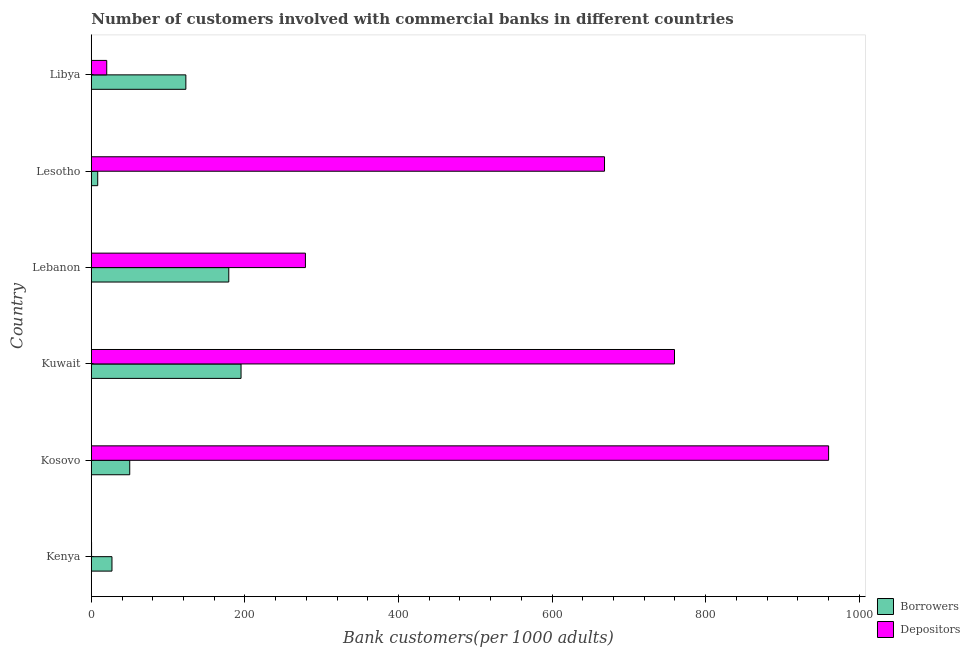How many groups of bars are there?
Your response must be concise. 6. Are the number of bars per tick equal to the number of legend labels?
Offer a terse response. Yes. How many bars are there on the 4th tick from the top?
Make the answer very short. 2. What is the label of the 2nd group of bars from the top?
Provide a short and direct response. Lesotho. What is the number of depositors in Kosovo?
Your answer should be compact. 960.24. Across all countries, what is the maximum number of depositors?
Ensure brevity in your answer.  960.24. Across all countries, what is the minimum number of borrowers?
Your answer should be compact. 8.36. In which country was the number of borrowers maximum?
Keep it short and to the point. Kuwait. In which country was the number of borrowers minimum?
Make the answer very short. Lesotho. What is the total number of depositors in the graph?
Offer a very short reply. 2687.5. What is the difference between the number of depositors in Kenya and that in Libya?
Keep it short and to the point. -19.77. What is the difference between the number of borrowers in Kuwait and the number of depositors in Lebanon?
Make the answer very short. -83.83. What is the average number of depositors per country?
Offer a terse response. 447.92. What is the difference between the number of borrowers and number of depositors in Kenya?
Make the answer very short. 26.58. What is the ratio of the number of depositors in Kenya to that in Kosovo?
Make the answer very short. 0. Is the number of depositors in Kenya less than that in Lesotho?
Make the answer very short. Yes. Is the difference between the number of borrowers in Kuwait and Lebanon greater than the difference between the number of depositors in Kuwait and Lebanon?
Your answer should be compact. No. What is the difference between the highest and the second highest number of depositors?
Your response must be concise. 200.7. What is the difference between the highest and the lowest number of depositors?
Your answer should be very brief. 959.89. In how many countries, is the number of borrowers greater than the average number of borrowers taken over all countries?
Your response must be concise. 3. Is the sum of the number of depositors in Lebanon and Lesotho greater than the maximum number of borrowers across all countries?
Keep it short and to the point. Yes. What does the 2nd bar from the top in Kosovo represents?
Provide a short and direct response. Borrowers. What does the 1st bar from the bottom in Kuwait represents?
Make the answer very short. Borrowers. Are all the bars in the graph horizontal?
Your answer should be very brief. Yes. How many countries are there in the graph?
Your answer should be compact. 6. Does the graph contain any zero values?
Your answer should be very brief. No. Does the graph contain grids?
Ensure brevity in your answer.  No. Where does the legend appear in the graph?
Your answer should be compact. Bottom right. How many legend labels are there?
Offer a terse response. 2. How are the legend labels stacked?
Offer a very short reply. Vertical. What is the title of the graph?
Your response must be concise. Number of customers involved with commercial banks in different countries. What is the label or title of the X-axis?
Provide a short and direct response. Bank customers(per 1000 adults). What is the Bank customers(per 1000 adults) of Borrowers in Kenya?
Your answer should be compact. 26.93. What is the Bank customers(per 1000 adults) of Depositors in Kenya?
Your answer should be compact. 0.35. What is the Bank customers(per 1000 adults) of Borrowers in Kosovo?
Your response must be concise. 50.07. What is the Bank customers(per 1000 adults) of Depositors in Kosovo?
Ensure brevity in your answer.  960.24. What is the Bank customers(per 1000 adults) of Borrowers in Kuwait?
Your answer should be very brief. 195.03. What is the Bank customers(per 1000 adults) of Depositors in Kuwait?
Ensure brevity in your answer.  759.54. What is the Bank customers(per 1000 adults) in Borrowers in Lebanon?
Offer a terse response. 179.06. What is the Bank customers(per 1000 adults) in Depositors in Lebanon?
Keep it short and to the point. 278.86. What is the Bank customers(per 1000 adults) of Borrowers in Lesotho?
Your response must be concise. 8.36. What is the Bank customers(per 1000 adults) of Depositors in Lesotho?
Your answer should be very brief. 668.4. What is the Bank customers(per 1000 adults) in Borrowers in Libya?
Offer a very short reply. 123.15. What is the Bank customers(per 1000 adults) of Depositors in Libya?
Offer a terse response. 20.11. Across all countries, what is the maximum Bank customers(per 1000 adults) in Borrowers?
Provide a short and direct response. 195.03. Across all countries, what is the maximum Bank customers(per 1000 adults) of Depositors?
Give a very brief answer. 960.24. Across all countries, what is the minimum Bank customers(per 1000 adults) in Borrowers?
Give a very brief answer. 8.36. Across all countries, what is the minimum Bank customers(per 1000 adults) of Depositors?
Provide a short and direct response. 0.35. What is the total Bank customers(per 1000 adults) in Borrowers in the graph?
Offer a very short reply. 582.61. What is the total Bank customers(per 1000 adults) of Depositors in the graph?
Your answer should be compact. 2687.5. What is the difference between the Bank customers(per 1000 adults) of Borrowers in Kenya and that in Kosovo?
Make the answer very short. -23.14. What is the difference between the Bank customers(per 1000 adults) of Depositors in Kenya and that in Kosovo?
Offer a terse response. -959.89. What is the difference between the Bank customers(per 1000 adults) in Borrowers in Kenya and that in Kuwait?
Keep it short and to the point. -168.1. What is the difference between the Bank customers(per 1000 adults) of Depositors in Kenya and that in Kuwait?
Your answer should be compact. -759.19. What is the difference between the Bank customers(per 1000 adults) of Borrowers in Kenya and that in Lebanon?
Provide a short and direct response. -152.13. What is the difference between the Bank customers(per 1000 adults) of Depositors in Kenya and that in Lebanon?
Offer a terse response. -278.52. What is the difference between the Bank customers(per 1000 adults) in Borrowers in Kenya and that in Lesotho?
Give a very brief answer. 18.56. What is the difference between the Bank customers(per 1000 adults) of Depositors in Kenya and that in Lesotho?
Ensure brevity in your answer.  -668.05. What is the difference between the Bank customers(per 1000 adults) of Borrowers in Kenya and that in Libya?
Provide a short and direct response. -96.22. What is the difference between the Bank customers(per 1000 adults) in Depositors in Kenya and that in Libya?
Your answer should be compact. -19.77. What is the difference between the Bank customers(per 1000 adults) in Borrowers in Kosovo and that in Kuwait?
Give a very brief answer. -144.96. What is the difference between the Bank customers(per 1000 adults) in Depositors in Kosovo and that in Kuwait?
Offer a very short reply. 200.7. What is the difference between the Bank customers(per 1000 adults) in Borrowers in Kosovo and that in Lebanon?
Ensure brevity in your answer.  -128.99. What is the difference between the Bank customers(per 1000 adults) in Depositors in Kosovo and that in Lebanon?
Keep it short and to the point. 681.38. What is the difference between the Bank customers(per 1000 adults) in Borrowers in Kosovo and that in Lesotho?
Give a very brief answer. 41.7. What is the difference between the Bank customers(per 1000 adults) in Depositors in Kosovo and that in Lesotho?
Provide a succinct answer. 291.84. What is the difference between the Bank customers(per 1000 adults) of Borrowers in Kosovo and that in Libya?
Offer a terse response. -73.08. What is the difference between the Bank customers(per 1000 adults) in Depositors in Kosovo and that in Libya?
Offer a terse response. 940.12. What is the difference between the Bank customers(per 1000 adults) in Borrowers in Kuwait and that in Lebanon?
Your response must be concise. 15.97. What is the difference between the Bank customers(per 1000 adults) in Depositors in Kuwait and that in Lebanon?
Your answer should be very brief. 480.68. What is the difference between the Bank customers(per 1000 adults) in Borrowers in Kuwait and that in Lesotho?
Provide a succinct answer. 186.67. What is the difference between the Bank customers(per 1000 adults) of Depositors in Kuwait and that in Lesotho?
Ensure brevity in your answer.  91.14. What is the difference between the Bank customers(per 1000 adults) of Borrowers in Kuwait and that in Libya?
Ensure brevity in your answer.  71.88. What is the difference between the Bank customers(per 1000 adults) in Depositors in Kuwait and that in Libya?
Make the answer very short. 739.42. What is the difference between the Bank customers(per 1000 adults) of Borrowers in Lebanon and that in Lesotho?
Ensure brevity in your answer.  170.7. What is the difference between the Bank customers(per 1000 adults) in Depositors in Lebanon and that in Lesotho?
Offer a terse response. -389.53. What is the difference between the Bank customers(per 1000 adults) of Borrowers in Lebanon and that in Libya?
Your response must be concise. 55.91. What is the difference between the Bank customers(per 1000 adults) in Depositors in Lebanon and that in Libya?
Provide a short and direct response. 258.75. What is the difference between the Bank customers(per 1000 adults) of Borrowers in Lesotho and that in Libya?
Offer a very short reply. -114.79. What is the difference between the Bank customers(per 1000 adults) in Depositors in Lesotho and that in Libya?
Keep it short and to the point. 648.28. What is the difference between the Bank customers(per 1000 adults) in Borrowers in Kenya and the Bank customers(per 1000 adults) in Depositors in Kosovo?
Keep it short and to the point. -933.31. What is the difference between the Bank customers(per 1000 adults) of Borrowers in Kenya and the Bank customers(per 1000 adults) of Depositors in Kuwait?
Your answer should be very brief. -732.61. What is the difference between the Bank customers(per 1000 adults) in Borrowers in Kenya and the Bank customers(per 1000 adults) in Depositors in Lebanon?
Offer a very short reply. -251.94. What is the difference between the Bank customers(per 1000 adults) in Borrowers in Kenya and the Bank customers(per 1000 adults) in Depositors in Lesotho?
Your answer should be compact. -641.47. What is the difference between the Bank customers(per 1000 adults) in Borrowers in Kenya and the Bank customers(per 1000 adults) in Depositors in Libya?
Your answer should be compact. 6.81. What is the difference between the Bank customers(per 1000 adults) in Borrowers in Kosovo and the Bank customers(per 1000 adults) in Depositors in Kuwait?
Keep it short and to the point. -709.47. What is the difference between the Bank customers(per 1000 adults) of Borrowers in Kosovo and the Bank customers(per 1000 adults) of Depositors in Lebanon?
Keep it short and to the point. -228.79. What is the difference between the Bank customers(per 1000 adults) in Borrowers in Kosovo and the Bank customers(per 1000 adults) in Depositors in Lesotho?
Give a very brief answer. -618.33. What is the difference between the Bank customers(per 1000 adults) of Borrowers in Kosovo and the Bank customers(per 1000 adults) of Depositors in Libya?
Make the answer very short. 29.95. What is the difference between the Bank customers(per 1000 adults) in Borrowers in Kuwait and the Bank customers(per 1000 adults) in Depositors in Lebanon?
Ensure brevity in your answer.  -83.83. What is the difference between the Bank customers(per 1000 adults) in Borrowers in Kuwait and the Bank customers(per 1000 adults) in Depositors in Lesotho?
Your answer should be compact. -473.36. What is the difference between the Bank customers(per 1000 adults) of Borrowers in Kuwait and the Bank customers(per 1000 adults) of Depositors in Libya?
Provide a succinct answer. 174.92. What is the difference between the Bank customers(per 1000 adults) of Borrowers in Lebanon and the Bank customers(per 1000 adults) of Depositors in Lesotho?
Ensure brevity in your answer.  -489.33. What is the difference between the Bank customers(per 1000 adults) of Borrowers in Lebanon and the Bank customers(per 1000 adults) of Depositors in Libya?
Provide a short and direct response. 158.95. What is the difference between the Bank customers(per 1000 adults) in Borrowers in Lesotho and the Bank customers(per 1000 adults) in Depositors in Libya?
Your answer should be compact. -11.75. What is the average Bank customers(per 1000 adults) in Borrowers per country?
Provide a short and direct response. 97.1. What is the average Bank customers(per 1000 adults) in Depositors per country?
Provide a short and direct response. 447.92. What is the difference between the Bank customers(per 1000 adults) in Borrowers and Bank customers(per 1000 adults) in Depositors in Kenya?
Offer a terse response. 26.58. What is the difference between the Bank customers(per 1000 adults) in Borrowers and Bank customers(per 1000 adults) in Depositors in Kosovo?
Keep it short and to the point. -910.17. What is the difference between the Bank customers(per 1000 adults) of Borrowers and Bank customers(per 1000 adults) of Depositors in Kuwait?
Give a very brief answer. -564.51. What is the difference between the Bank customers(per 1000 adults) in Borrowers and Bank customers(per 1000 adults) in Depositors in Lebanon?
Your answer should be compact. -99.8. What is the difference between the Bank customers(per 1000 adults) in Borrowers and Bank customers(per 1000 adults) in Depositors in Lesotho?
Offer a terse response. -660.03. What is the difference between the Bank customers(per 1000 adults) in Borrowers and Bank customers(per 1000 adults) in Depositors in Libya?
Your answer should be compact. 103.04. What is the ratio of the Bank customers(per 1000 adults) in Borrowers in Kenya to that in Kosovo?
Keep it short and to the point. 0.54. What is the ratio of the Bank customers(per 1000 adults) in Borrowers in Kenya to that in Kuwait?
Provide a short and direct response. 0.14. What is the ratio of the Bank customers(per 1000 adults) in Depositors in Kenya to that in Kuwait?
Offer a very short reply. 0. What is the ratio of the Bank customers(per 1000 adults) of Borrowers in Kenya to that in Lebanon?
Provide a succinct answer. 0.15. What is the ratio of the Bank customers(per 1000 adults) in Depositors in Kenya to that in Lebanon?
Offer a very short reply. 0. What is the ratio of the Bank customers(per 1000 adults) of Borrowers in Kenya to that in Lesotho?
Give a very brief answer. 3.22. What is the ratio of the Bank customers(per 1000 adults) in Borrowers in Kenya to that in Libya?
Your response must be concise. 0.22. What is the ratio of the Bank customers(per 1000 adults) of Depositors in Kenya to that in Libya?
Make the answer very short. 0.02. What is the ratio of the Bank customers(per 1000 adults) of Borrowers in Kosovo to that in Kuwait?
Give a very brief answer. 0.26. What is the ratio of the Bank customers(per 1000 adults) in Depositors in Kosovo to that in Kuwait?
Your answer should be very brief. 1.26. What is the ratio of the Bank customers(per 1000 adults) of Borrowers in Kosovo to that in Lebanon?
Your response must be concise. 0.28. What is the ratio of the Bank customers(per 1000 adults) in Depositors in Kosovo to that in Lebanon?
Keep it short and to the point. 3.44. What is the ratio of the Bank customers(per 1000 adults) in Borrowers in Kosovo to that in Lesotho?
Provide a short and direct response. 5.99. What is the ratio of the Bank customers(per 1000 adults) of Depositors in Kosovo to that in Lesotho?
Keep it short and to the point. 1.44. What is the ratio of the Bank customers(per 1000 adults) of Borrowers in Kosovo to that in Libya?
Ensure brevity in your answer.  0.41. What is the ratio of the Bank customers(per 1000 adults) in Depositors in Kosovo to that in Libya?
Provide a short and direct response. 47.74. What is the ratio of the Bank customers(per 1000 adults) of Borrowers in Kuwait to that in Lebanon?
Your response must be concise. 1.09. What is the ratio of the Bank customers(per 1000 adults) of Depositors in Kuwait to that in Lebanon?
Keep it short and to the point. 2.72. What is the ratio of the Bank customers(per 1000 adults) of Borrowers in Kuwait to that in Lesotho?
Provide a short and direct response. 23.32. What is the ratio of the Bank customers(per 1000 adults) of Depositors in Kuwait to that in Lesotho?
Offer a very short reply. 1.14. What is the ratio of the Bank customers(per 1000 adults) in Borrowers in Kuwait to that in Libya?
Keep it short and to the point. 1.58. What is the ratio of the Bank customers(per 1000 adults) in Depositors in Kuwait to that in Libya?
Provide a succinct answer. 37.76. What is the ratio of the Bank customers(per 1000 adults) of Borrowers in Lebanon to that in Lesotho?
Your response must be concise. 21.41. What is the ratio of the Bank customers(per 1000 adults) of Depositors in Lebanon to that in Lesotho?
Provide a short and direct response. 0.42. What is the ratio of the Bank customers(per 1000 adults) in Borrowers in Lebanon to that in Libya?
Make the answer very short. 1.45. What is the ratio of the Bank customers(per 1000 adults) of Depositors in Lebanon to that in Libya?
Keep it short and to the point. 13.86. What is the ratio of the Bank customers(per 1000 adults) in Borrowers in Lesotho to that in Libya?
Keep it short and to the point. 0.07. What is the ratio of the Bank customers(per 1000 adults) of Depositors in Lesotho to that in Libya?
Your answer should be very brief. 33.23. What is the difference between the highest and the second highest Bank customers(per 1000 adults) of Borrowers?
Provide a short and direct response. 15.97. What is the difference between the highest and the second highest Bank customers(per 1000 adults) in Depositors?
Your answer should be compact. 200.7. What is the difference between the highest and the lowest Bank customers(per 1000 adults) in Borrowers?
Provide a succinct answer. 186.67. What is the difference between the highest and the lowest Bank customers(per 1000 adults) of Depositors?
Ensure brevity in your answer.  959.89. 